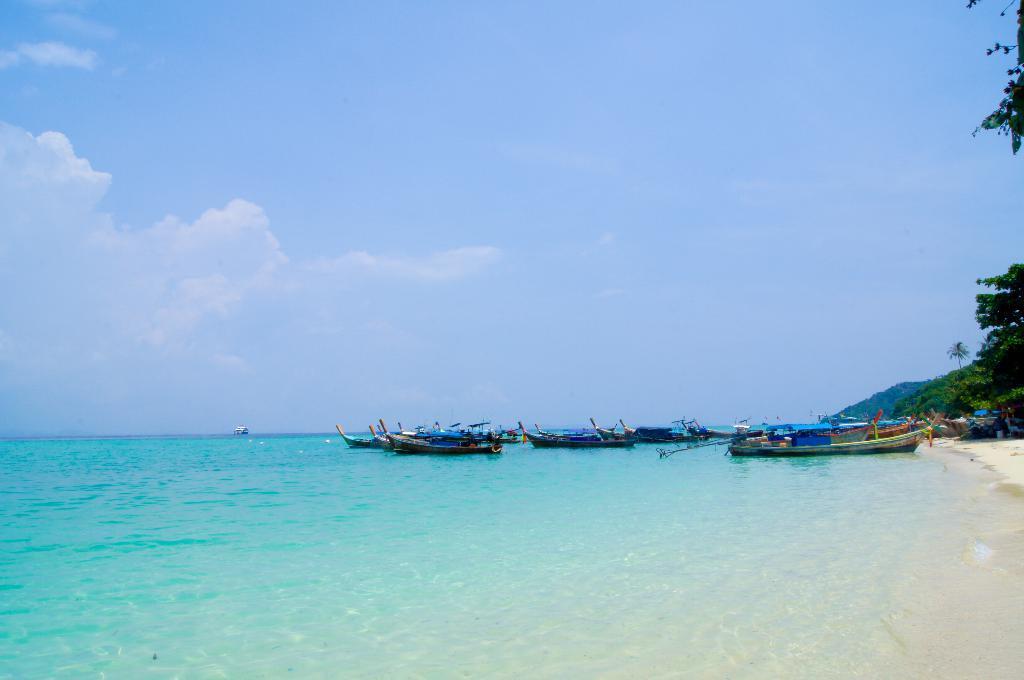Describe this image in one or two sentences. In this image we can see a large water body. We can also see some boats on a sea shore. On the backside we can see a group of trees, the hill and the sky which looks cloudy. 